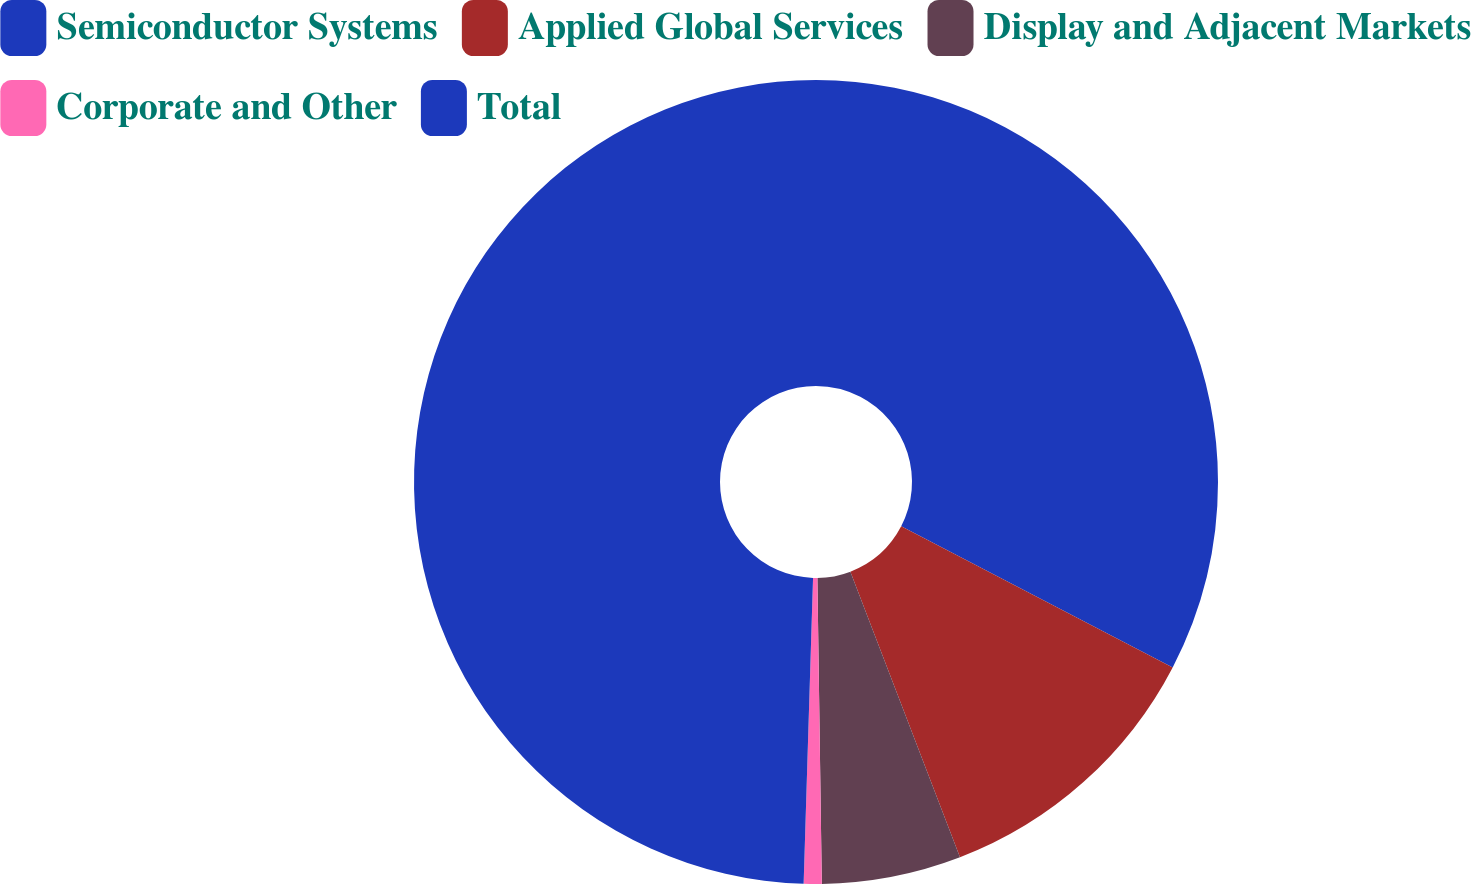Convert chart to OTSL. <chart><loc_0><loc_0><loc_500><loc_500><pie_chart><fcel>Semiconductor Systems<fcel>Applied Global Services<fcel>Display and Adjacent Markets<fcel>Corporate and Other<fcel>Total<nl><fcel>32.63%<fcel>11.54%<fcel>5.6%<fcel>0.72%<fcel>49.51%<nl></chart> 